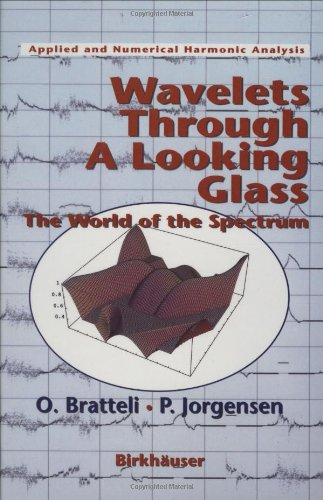What is the title of this book? The full title of the book is 'Wavelets Through a Looking Glass: The World of the Spectrum', a volume in the Applied and Numerical Harmonic Analysis series. 